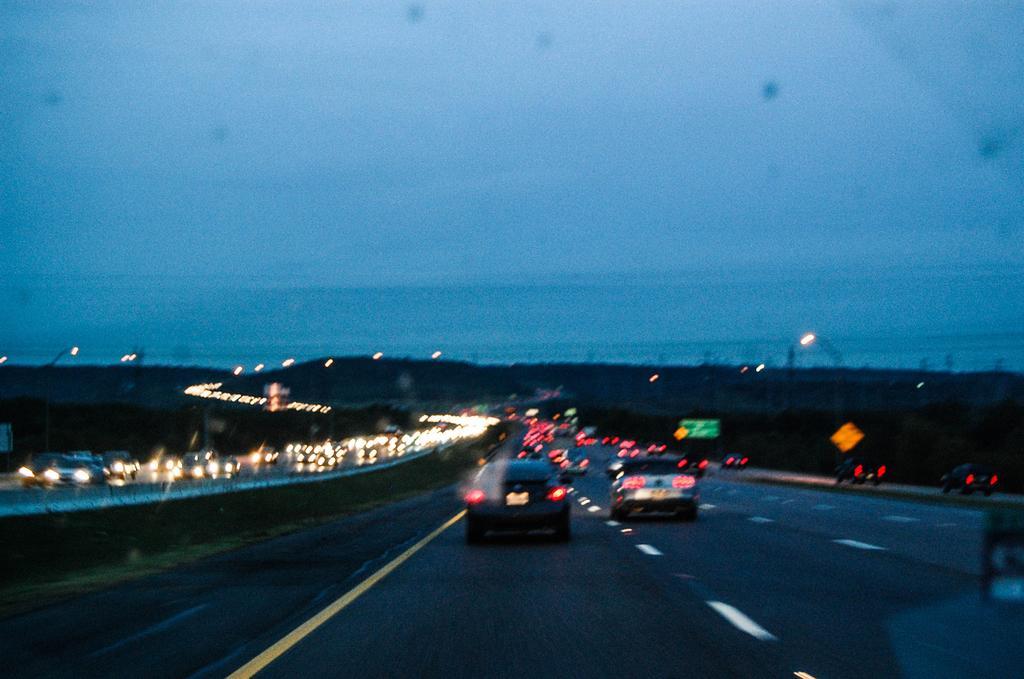In one or two sentences, can you explain what this image depicts? In this picture we can see vehicles on the road, lights, sign boards and in the background we can see the sky. 